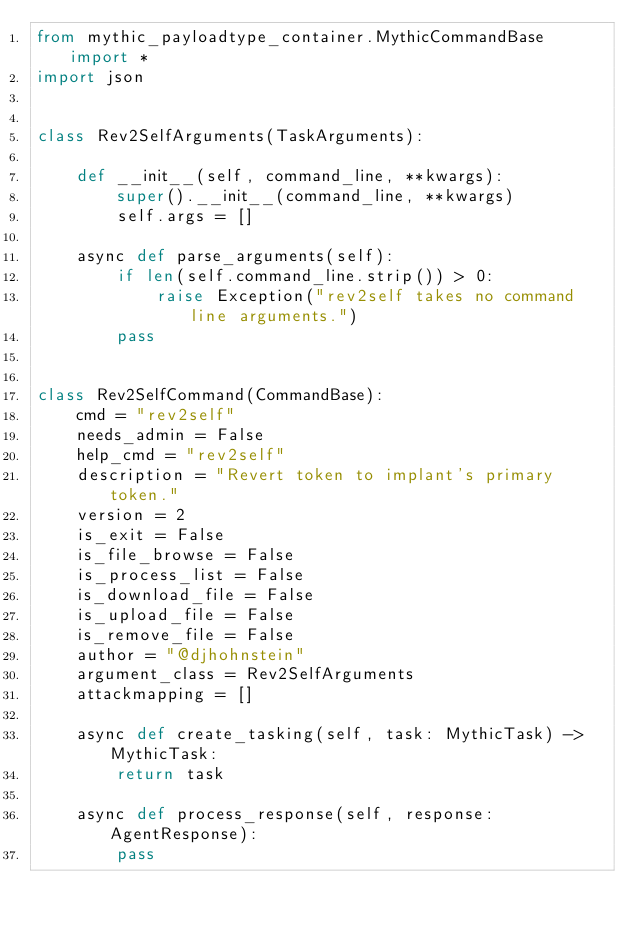<code> <loc_0><loc_0><loc_500><loc_500><_Python_>from mythic_payloadtype_container.MythicCommandBase import *
import json


class Rev2SelfArguments(TaskArguments):

    def __init__(self, command_line, **kwargs):
        super().__init__(command_line, **kwargs)
        self.args = []

    async def parse_arguments(self):
        if len(self.command_line.strip()) > 0:
            raise Exception("rev2self takes no command line arguments.")
        pass


class Rev2SelfCommand(CommandBase):
    cmd = "rev2self"
    needs_admin = False
    help_cmd = "rev2self"
    description = "Revert token to implant's primary token."
    version = 2
    is_exit = False
    is_file_browse = False
    is_process_list = False
    is_download_file = False
    is_upload_file = False
    is_remove_file = False
    author = "@djhohnstein"
    argument_class = Rev2SelfArguments
    attackmapping = []

    async def create_tasking(self, task: MythicTask) -> MythicTask:
        return task

    async def process_response(self, response: AgentResponse):
        pass</code> 